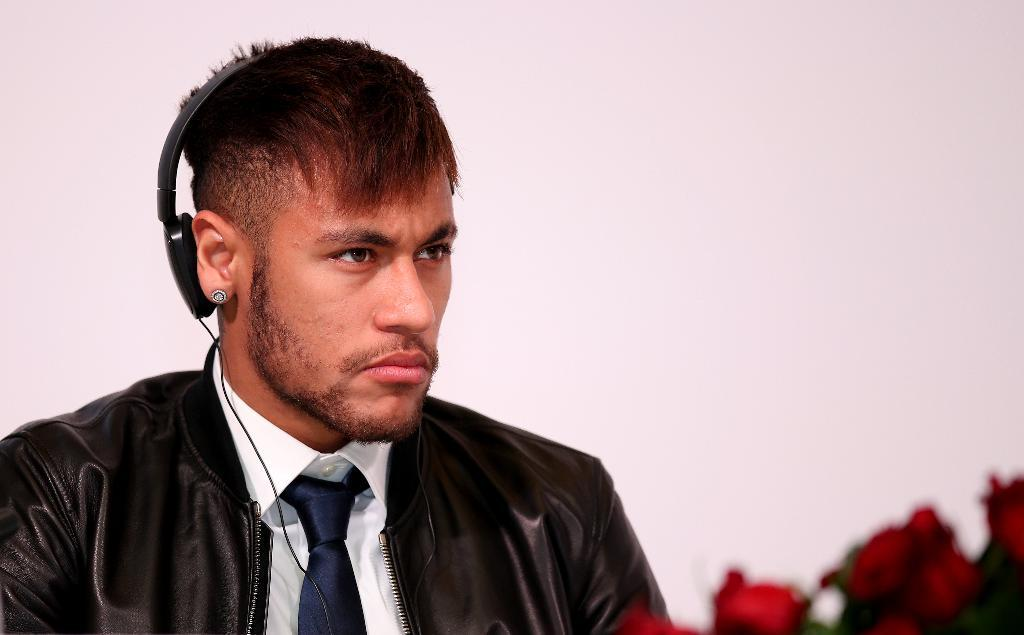Who or what is the main subject in the image? There is a person in the image. What is the color of the background in the image? The person is on a white background. What is the person wearing in the image? The person is wearing clothes and a headset. Where are the flowers located in the image? The flowers are in the bottom right of the image. What type of wire is being used by the person in the image? There is no wire visible in the image; the person is wearing a headset, but it is not specified whether it is wired or wireless. 